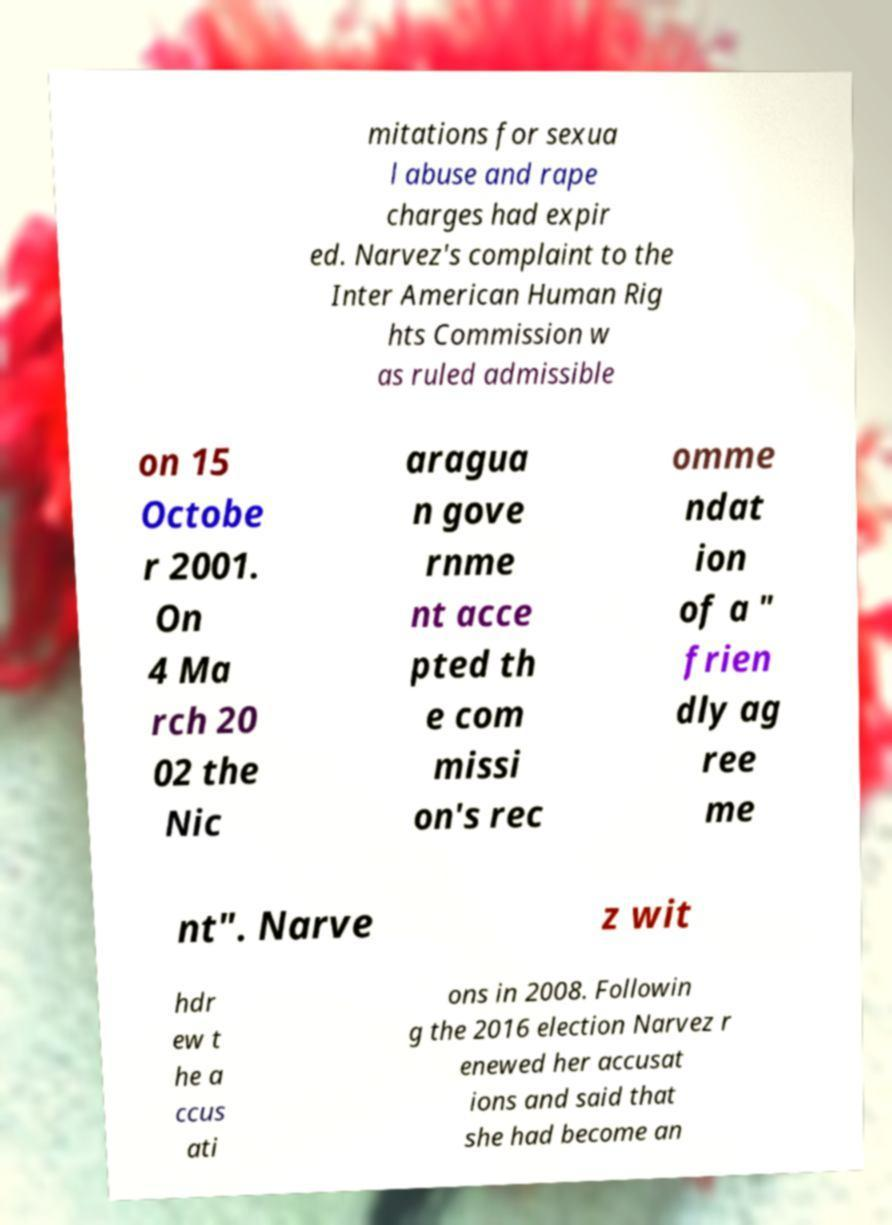I need the written content from this picture converted into text. Can you do that? mitations for sexua l abuse and rape charges had expir ed. Narvez's complaint to the Inter American Human Rig hts Commission w as ruled admissible on 15 Octobe r 2001. On 4 Ma rch 20 02 the Nic aragua n gove rnme nt acce pted th e com missi on's rec omme ndat ion of a " frien dly ag ree me nt". Narve z wit hdr ew t he a ccus ati ons in 2008. Followin g the 2016 election Narvez r enewed her accusat ions and said that she had become an 